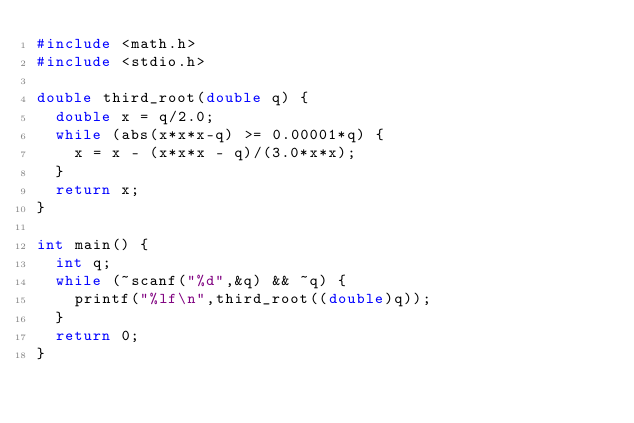<code> <loc_0><loc_0><loc_500><loc_500><_C_>#include <math.h>
#include <stdio.h>

double third_root(double q) {
	double x = q/2.0;
	while (abs(x*x*x-q) >= 0.00001*q) {
		x = x - (x*x*x - q)/(3.0*x*x);
	}
	return x;
}

int main() {
	int q;
	while (~scanf("%d",&q) && ~q) {
		printf("%lf\n",third_root((double)q));
	}
	return 0;
}</code> 